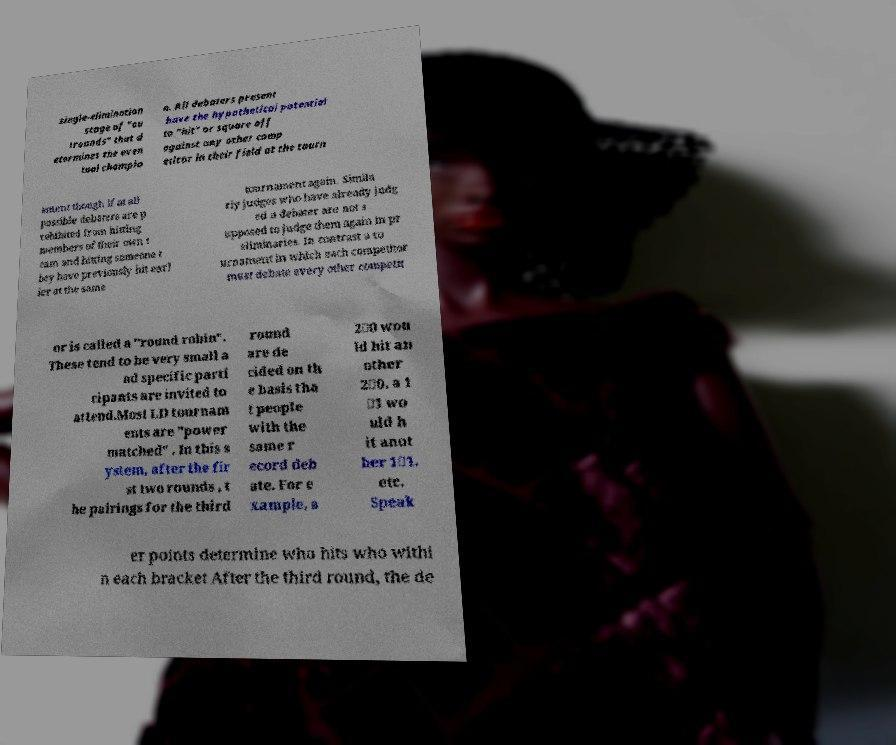There's text embedded in this image that I need extracted. Can you transcribe it verbatim? single-elimination stage of "ou trounds" that d etermines the even tual champio n. All debaters present have the hypothetical potential to "hit" or square off against any other comp etitor in their field at the tourn ament though if at all possible debaters are p rohibited from hitting members of their own t eam and hitting someone t hey have previously hit earl ier at the same tournament again. Simila rly judges who have already judg ed a debater are not s upposed to judge them again in pr eliminaries. In contrast a to urnament in which each competitor must debate every other competit or is called a "round robin". These tend to be very small a nd specific parti cipants are invited to attend.Most LD tournam ents are "power matched" . In this s ystem, after the fir st two rounds , t he pairings for the third round are de cided on th e basis tha t people with the same r ecord deb ate. For e xample, a 2‑0 wou ld hit an other 2‑0, a 1 ‑1 wo uld h it anot her 1‑1, etc. Speak er points determine who hits who withi n each bracket After the third round, the de 